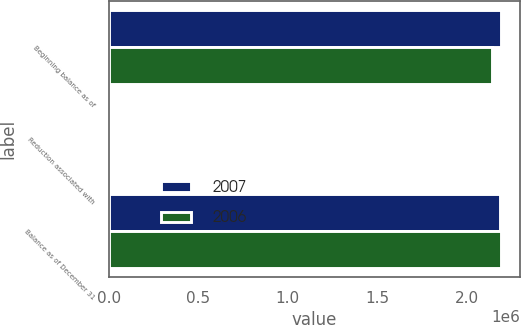Convert chart. <chart><loc_0><loc_0><loc_500><loc_500><stacked_bar_chart><ecel><fcel>Beginning balance as of<fcel>Reduction associated with<fcel>Balance as of December 31<nl><fcel>2007<fcel>2.18977e+06<fcel>1455<fcel>2.18831e+06<nl><fcel>2006<fcel>2.14255e+06<fcel>7247<fcel>2.18977e+06<nl></chart> 